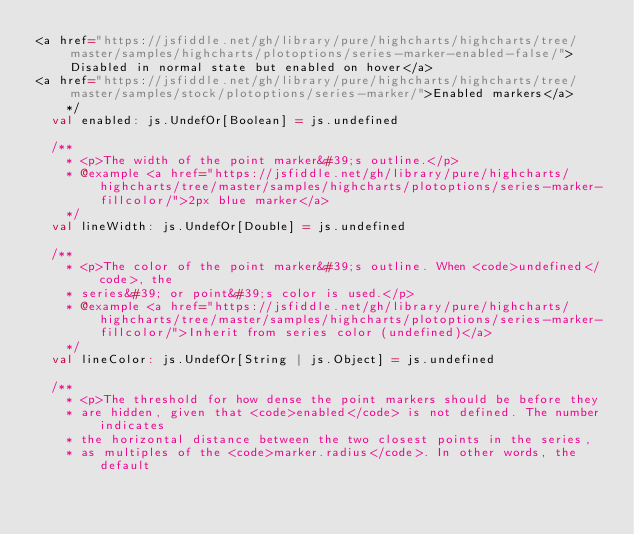<code> <loc_0><loc_0><loc_500><loc_500><_Scala_><a href="https://jsfiddle.net/gh/library/pure/highcharts/highcharts/tree/master/samples/highcharts/plotoptions/series-marker-enabled-false/">Disabled in normal state but enabled on hover</a>
<a href="https://jsfiddle.net/gh/library/pure/highcharts/highcharts/tree/master/samples/stock/plotoptions/series-marker/">Enabled markers</a>
    */
  val enabled: js.UndefOr[Boolean] = js.undefined

  /**
    * <p>The width of the point marker&#39;s outline.</p>
    * @example <a href="https://jsfiddle.net/gh/library/pure/highcharts/highcharts/tree/master/samples/highcharts/plotoptions/series-marker-fillcolor/">2px blue marker</a>
    */
  val lineWidth: js.UndefOr[Double] = js.undefined

  /**
    * <p>The color of the point marker&#39;s outline. When <code>undefined</code>, the
    * series&#39; or point&#39;s color is used.</p>
    * @example <a href="https://jsfiddle.net/gh/library/pure/highcharts/highcharts/tree/master/samples/highcharts/plotoptions/series-marker-fillcolor/">Inherit from series color (undefined)</a>
    */
  val lineColor: js.UndefOr[String | js.Object] = js.undefined

  /**
    * <p>The threshold for how dense the point markers should be before they
    * are hidden, given that <code>enabled</code> is not defined. The number indicates
    * the horizontal distance between the two closest points in the series,
    * as multiples of the <code>marker.radius</code>. In other words, the default</code> 